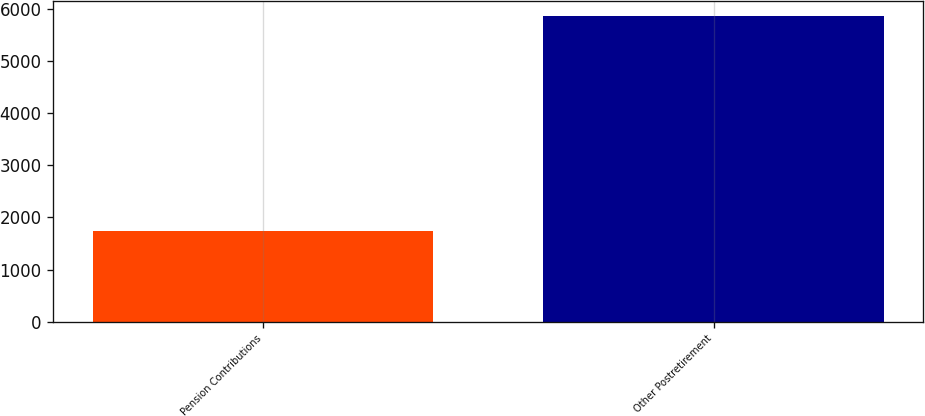Convert chart. <chart><loc_0><loc_0><loc_500><loc_500><bar_chart><fcel>Pension Contributions<fcel>Other Postretirement<nl><fcel>1739<fcel>5858<nl></chart> 